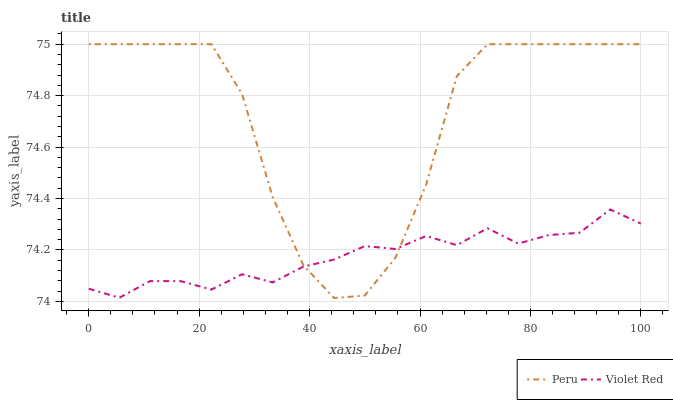Does Violet Red have the minimum area under the curve?
Answer yes or no. Yes. Does Peru have the maximum area under the curve?
Answer yes or no. Yes. Does Peru have the minimum area under the curve?
Answer yes or no. No. Is Violet Red the smoothest?
Answer yes or no. Yes. Is Peru the roughest?
Answer yes or no. Yes. Is Peru the smoothest?
Answer yes or no. No. Does Peru have the lowest value?
Answer yes or no. Yes. Does Peru have the highest value?
Answer yes or no. Yes. Does Violet Red intersect Peru?
Answer yes or no. Yes. Is Violet Red less than Peru?
Answer yes or no. No. Is Violet Red greater than Peru?
Answer yes or no. No. 